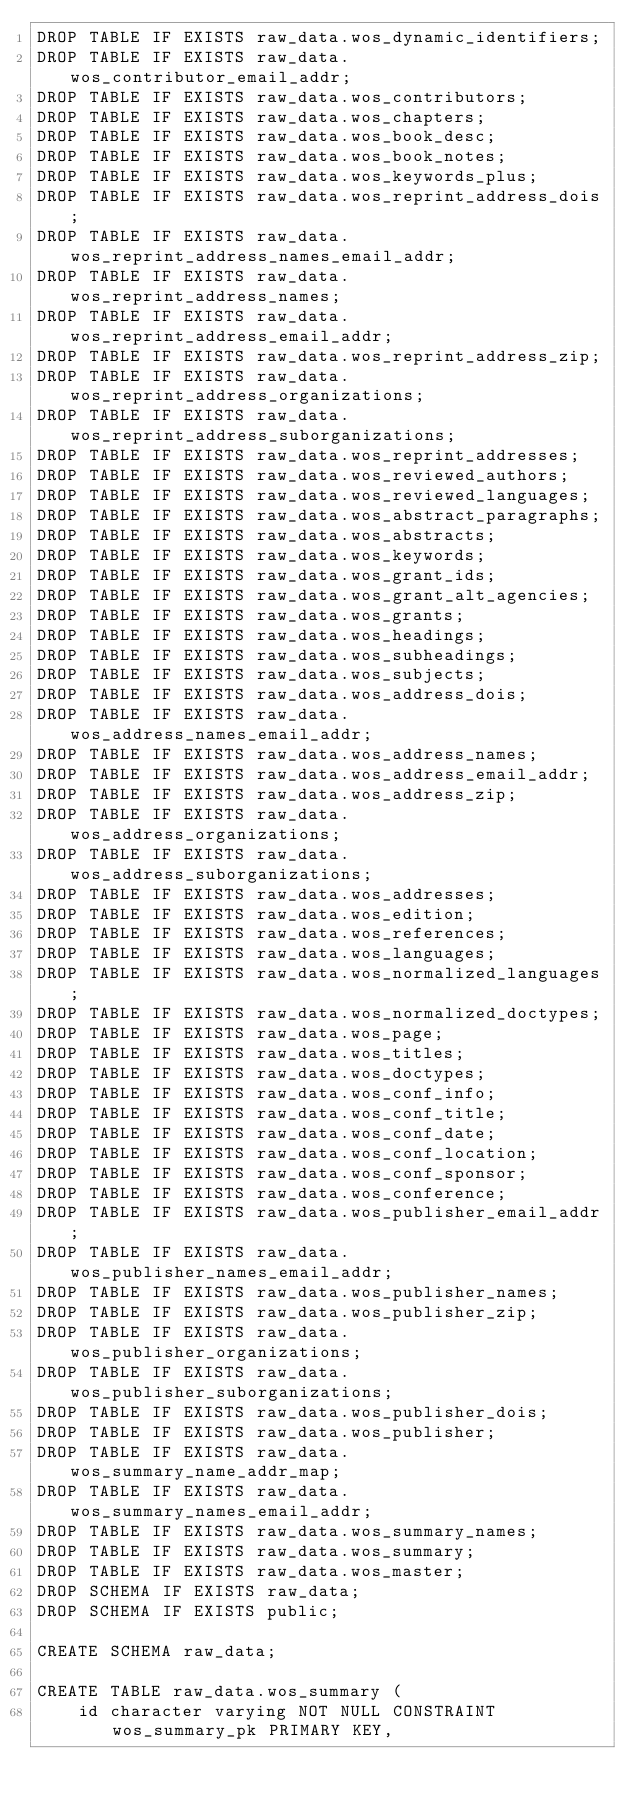<code> <loc_0><loc_0><loc_500><loc_500><_SQL_>DROP TABLE IF EXISTS raw_data.wos_dynamic_identifiers;
DROP TABLE IF EXISTS raw_data.wos_contributor_email_addr;
DROP TABLE IF EXISTS raw_data.wos_contributors;
DROP TABLE IF EXISTS raw_data.wos_chapters;
DROP TABLE IF EXISTS raw_data.wos_book_desc;
DROP TABLE IF EXISTS raw_data.wos_book_notes;
DROP TABLE IF EXISTS raw_data.wos_keywords_plus;
DROP TABLE IF EXISTS raw_data.wos_reprint_address_dois;
DROP TABLE IF EXISTS raw_data.wos_reprint_address_names_email_addr;
DROP TABLE IF EXISTS raw_data.wos_reprint_address_names;
DROP TABLE IF EXISTS raw_data.wos_reprint_address_email_addr;
DROP TABLE IF EXISTS raw_data.wos_reprint_address_zip;
DROP TABLE IF EXISTS raw_data.wos_reprint_address_organizations;
DROP TABLE IF EXISTS raw_data.wos_reprint_address_suborganizations;
DROP TABLE IF EXISTS raw_data.wos_reprint_addresses;
DROP TABLE IF EXISTS raw_data.wos_reviewed_authors;
DROP TABLE IF EXISTS raw_data.wos_reviewed_languages;
DROP TABLE IF EXISTS raw_data.wos_abstract_paragraphs;
DROP TABLE IF EXISTS raw_data.wos_abstracts;
DROP TABLE IF EXISTS raw_data.wos_keywords;
DROP TABLE IF EXISTS raw_data.wos_grant_ids;
DROP TABLE IF EXISTS raw_data.wos_grant_alt_agencies;
DROP TABLE IF EXISTS raw_data.wos_grants;
DROP TABLE IF EXISTS raw_data.wos_headings;
DROP TABLE IF EXISTS raw_data.wos_subheadings;
DROP TABLE IF EXISTS raw_data.wos_subjects;
DROP TABLE IF EXISTS raw_data.wos_address_dois;
DROP TABLE IF EXISTS raw_data.wos_address_names_email_addr;
DROP TABLE IF EXISTS raw_data.wos_address_names;
DROP TABLE IF EXISTS raw_data.wos_address_email_addr;
DROP TABLE IF EXISTS raw_data.wos_address_zip;
DROP TABLE IF EXISTS raw_data.wos_address_organizations;
DROP TABLE IF EXISTS raw_data.wos_address_suborganizations;
DROP TABLE IF EXISTS raw_data.wos_addresses;
DROP TABLE IF EXISTS raw_data.wos_edition;
DROP TABLE IF EXISTS raw_data.wos_references;
DROP TABLE IF EXISTS raw_data.wos_languages;
DROP TABLE IF EXISTS raw_data.wos_normalized_languages;
DROP TABLE IF EXISTS raw_data.wos_normalized_doctypes;
DROP TABLE IF EXISTS raw_data.wos_page;
DROP TABLE IF EXISTS raw_data.wos_titles;
DROP TABLE IF EXISTS raw_data.wos_doctypes;
DROP TABLE IF EXISTS raw_data.wos_conf_info;
DROP TABLE IF EXISTS raw_data.wos_conf_title;
DROP TABLE IF EXISTS raw_data.wos_conf_date;
DROP TABLE IF EXISTS raw_data.wos_conf_location;
DROP TABLE IF EXISTS raw_data.wos_conf_sponsor;
DROP TABLE IF EXISTS raw_data.wos_conference;
DROP TABLE IF EXISTS raw_data.wos_publisher_email_addr;
DROP TABLE IF EXISTS raw_data.wos_publisher_names_email_addr;
DROP TABLE IF EXISTS raw_data.wos_publisher_names;
DROP TABLE IF EXISTS raw_data.wos_publisher_zip;
DROP TABLE IF EXISTS raw_data.wos_publisher_organizations;
DROP TABLE IF EXISTS raw_data.wos_publisher_suborganizations;
DROP TABLE IF EXISTS raw_data.wos_publisher_dois;
DROP TABLE IF EXISTS raw_data.wos_publisher;
DROP TABLE IF EXISTS raw_data.wos_summary_name_addr_map;
DROP TABLE IF EXISTS raw_data.wos_summary_names_email_addr;
DROP TABLE IF EXISTS raw_data.wos_summary_names;
DROP TABLE IF EXISTS raw_data.wos_summary;
DROP TABLE IF EXISTS raw_data.wos_master;
DROP SCHEMA IF EXISTS raw_data;
DROP SCHEMA IF EXISTS public;

CREATE SCHEMA raw_data;

CREATE TABLE raw_data.wos_summary (
	id character varying NOT NULL CONSTRAINT wos_summary_pk PRIMARY KEY,</code> 